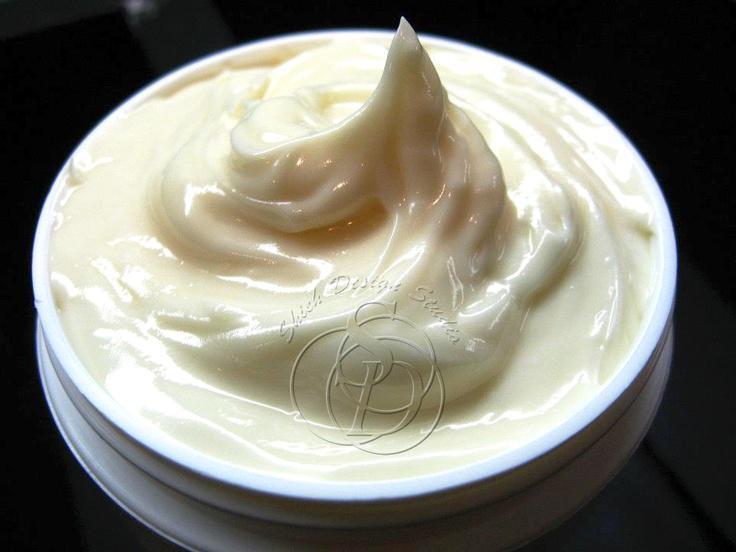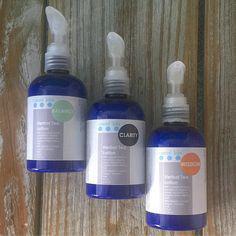The first image is the image on the left, the second image is the image on the right. For the images displayed, is the sentence "There are two glass jars and they are both open." factually correct? Answer yes or no. No. The first image is the image on the left, the second image is the image on the right. For the images displayed, is the sentence "Left and right images show similarly-shaped clear glass open-topped jars containing a creamy substance." factually correct? Answer yes or no. No. 